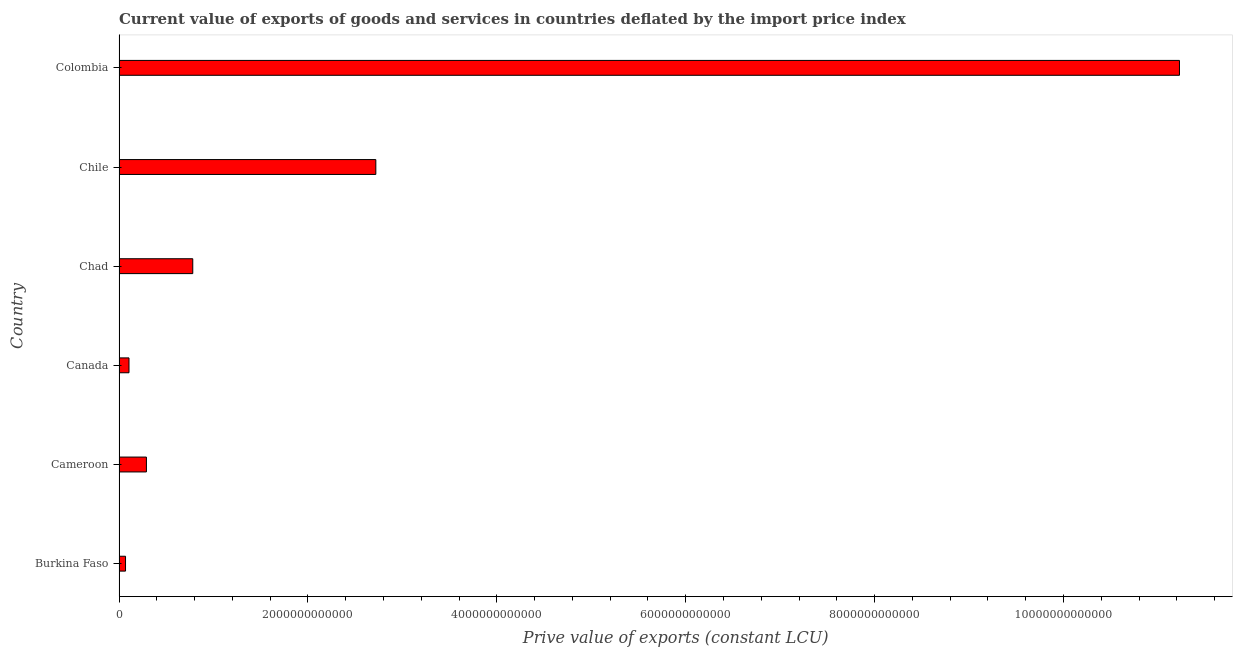What is the title of the graph?
Your response must be concise. Current value of exports of goods and services in countries deflated by the import price index. What is the label or title of the X-axis?
Keep it short and to the point. Prive value of exports (constant LCU). What is the label or title of the Y-axis?
Your answer should be compact. Country. What is the price value of exports in Canada?
Offer a terse response. 1.05e+11. Across all countries, what is the maximum price value of exports?
Provide a succinct answer. 1.12e+13. Across all countries, what is the minimum price value of exports?
Offer a terse response. 6.87e+1. In which country was the price value of exports maximum?
Offer a terse response. Colombia. In which country was the price value of exports minimum?
Your response must be concise. Burkina Faso. What is the sum of the price value of exports?
Your answer should be compact. 1.52e+13. What is the difference between the price value of exports in Burkina Faso and Cameroon?
Make the answer very short. -2.21e+11. What is the average price value of exports per country?
Your answer should be compact. 2.53e+12. What is the median price value of exports?
Make the answer very short. 5.35e+11. What is the ratio of the price value of exports in Canada to that in Chile?
Keep it short and to the point. 0.04. What is the difference between the highest and the second highest price value of exports?
Offer a terse response. 8.51e+12. What is the difference between the highest and the lowest price value of exports?
Provide a succinct answer. 1.12e+13. In how many countries, is the price value of exports greater than the average price value of exports taken over all countries?
Give a very brief answer. 2. What is the difference between two consecutive major ticks on the X-axis?
Offer a terse response. 2.00e+12. What is the Prive value of exports (constant LCU) in Burkina Faso?
Your response must be concise. 6.87e+1. What is the Prive value of exports (constant LCU) of Cameroon?
Your response must be concise. 2.90e+11. What is the Prive value of exports (constant LCU) in Canada?
Offer a terse response. 1.05e+11. What is the Prive value of exports (constant LCU) of Chad?
Your answer should be very brief. 7.81e+11. What is the Prive value of exports (constant LCU) of Chile?
Ensure brevity in your answer.  2.72e+12. What is the Prive value of exports (constant LCU) in Colombia?
Give a very brief answer. 1.12e+13. What is the difference between the Prive value of exports (constant LCU) in Burkina Faso and Cameroon?
Your answer should be compact. -2.21e+11. What is the difference between the Prive value of exports (constant LCU) in Burkina Faso and Canada?
Provide a succinct answer. -3.66e+1. What is the difference between the Prive value of exports (constant LCU) in Burkina Faso and Chad?
Offer a terse response. -7.12e+11. What is the difference between the Prive value of exports (constant LCU) in Burkina Faso and Chile?
Your response must be concise. -2.65e+12. What is the difference between the Prive value of exports (constant LCU) in Burkina Faso and Colombia?
Your answer should be compact. -1.12e+13. What is the difference between the Prive value of exports (constant LCU) in Cameroon and Canada?
Your answer should be compact. 1.85e+11. What is the difference between the Prive value of exports (constant LCU) in Cameroon and Chad?
Your answer should be very brief. -4.91e+11. What is the difference between the Prive value of exports (constant LCU) in Cameroon and Chile?
Offer a terse response. -2.43e+12. What is the difference between the Prive value of exports (constant LCU) in Cameroon and Colombia?
Offer a terse response. -1.09e+13. What is the difference between the Prive value of exports (constant LCU) in Canada and Chad?
Your answer should be very brief. -6.75e+11. What is the difference between the Prive value of exports (constant LCU) in Canada and Chile?
Your response must be concise. -2.61e+12. What is the difference between the Prive value of exports (constant LCU) in Canada and Colombia?
Offer a very short reply. -1.11e+13. What is the difference between the Prive value of exports (constant LCU) in Chad and Chile?
Offer a terse response. -1.94e+12. What is the difference between the Prive value of exports (constant LCU) in Chad and Colombia?
Your response must be concise. -1.04e+13. What is the difference between the Prive value of exports (constant LCU) in Chile and Colombia?
Offer a terse response. -8.51e+12. What is the ratio of the Prive value of exports (constant LCU) in Burkina Faso to that in Cameroon?
Make the answer very short. 0.24. What is the ratio of the Prive value of exports (constant LCU) in Burkina Faso to that in Canada?
Your response must be concise. 0.65. What is the ratio of the Prive value of exports (constant LCU) in Burkina Faso to that in Chad?
Give a very brief answer. 0.09. What is the ratio of the Prive value of exports (constant LCU) in Burkina Faso to that in Chile?
Provide a succinct answer. 0.03. What is the ratio of the Prive value of exports (constant LCU) in Burkina Faso to that in Colombia?
Make the answer very short. 0.01. What is the ratio of the Prive value of exports (constant LCU) in Cameroon to that in Canada?
Give a very brief answer. 2.75. What is the ratio of the Prive value of exports (constant LCU) in Cameroon to that in Chad?
Provide a short and direct response. 0.37. What is the ratio of the Prive value of exports (constant LCU) in Cameroon to that in Chile?
Ensure brevity in your answer.  0.11. What is the ratio of the Prive value of exports (constant LCU) in Cameroon to that in Colombia?
Make the answer very short. 0.03. What is the ratio of the Prive value of exports (constant LCU) in Canada to that in Chad?
Ensure brevity in your answer.  0.14. What is the ratio of the Prive value of exports (constant LCU) in Canada to that in Chile?
Offer a terse response. 0.04. What is the ratio of the Prive value of exports (constant LCU) in Canada to that in Colombia?
Give a very brief answer. 0.01. What is the ratio of the Prive value of exports (constant LCU) in Chad to that in Chile?
Provide a short and direct response. 0.29. What is the ratio of the Prive value of exports (constant LCU) in Chad to that in Colombia?
Provide a short and direct response. 0.07. What is the ratio of the Prive value of exports (constant LCU) in Chile to that in Colombia?
Provide a short and direct response. 0.24. 